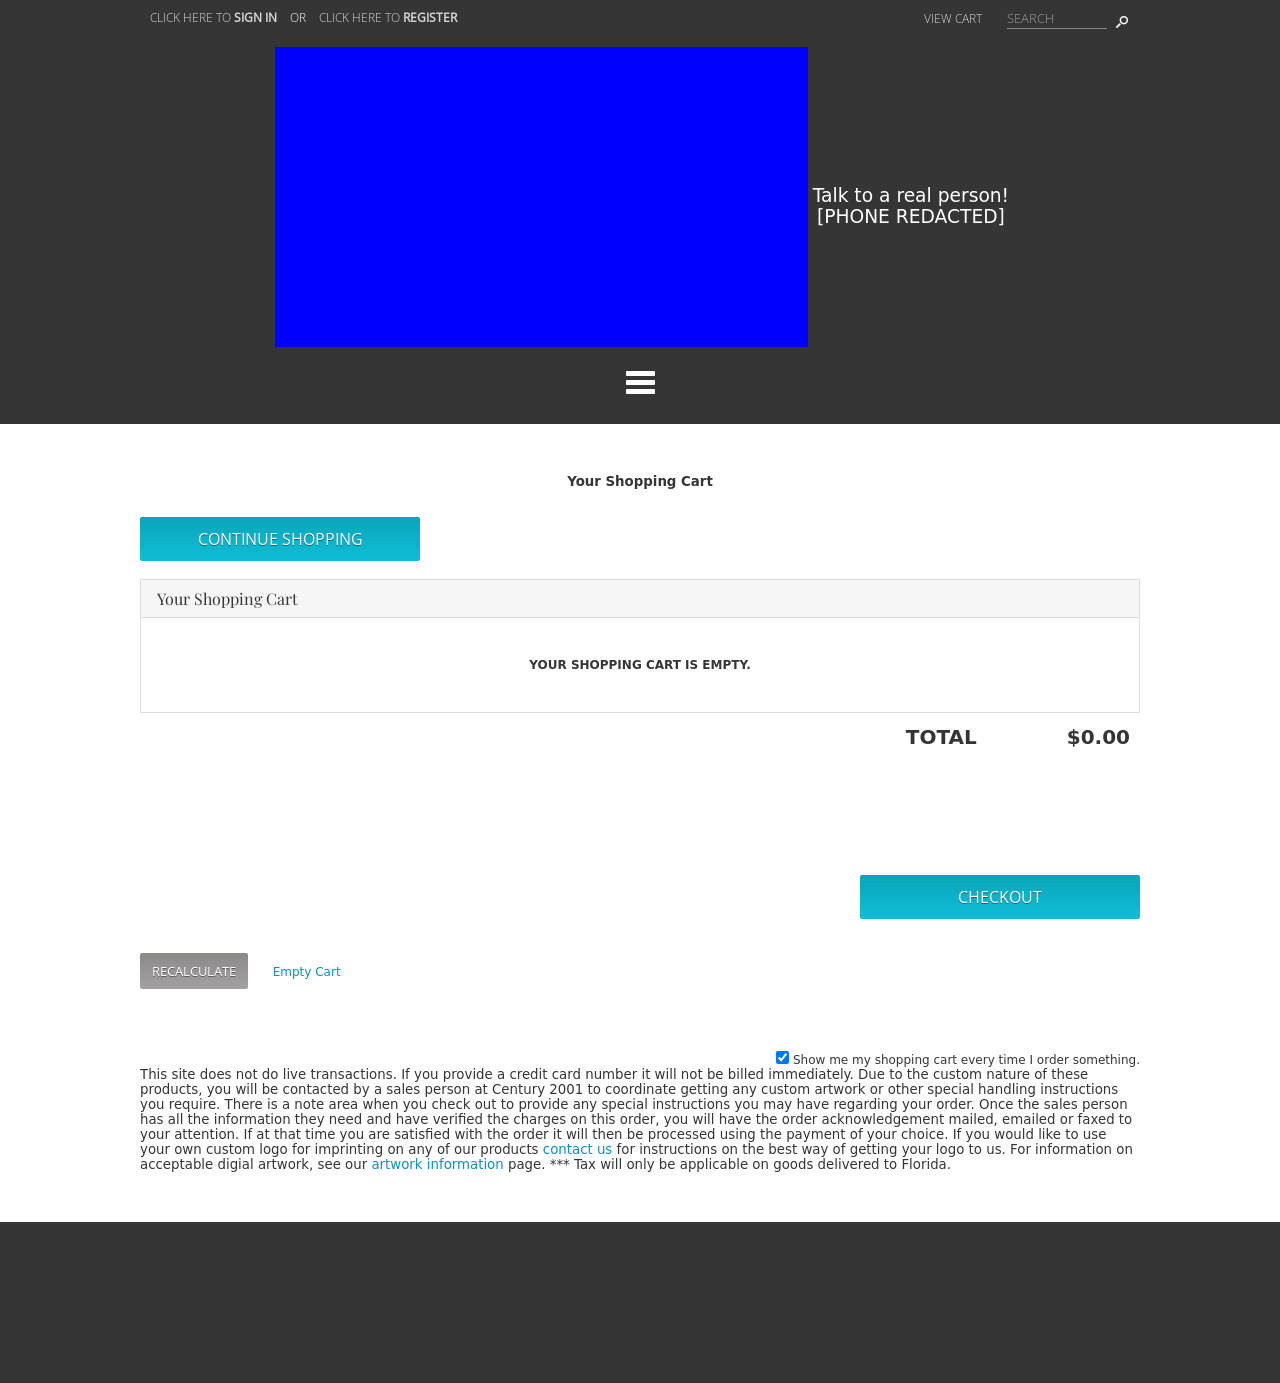Could you suggest some colors that would suit the theme of this website intended for a technology startup? For a technology startup, consider a color palette that includes shades of blue, which convey trust and security, combined with grays and whites for a clean, modern look. Additionally, adding a vibrant accent color like green or orange can bring energy and innovation to the design. 